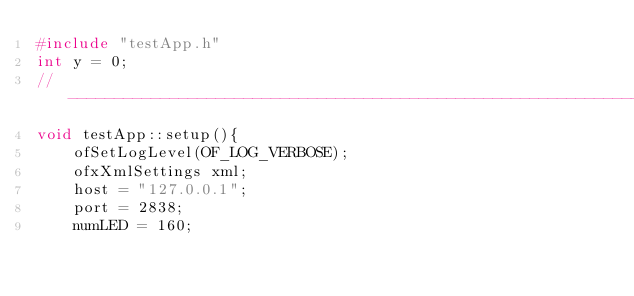Convert code to text. <code><loc_0><loc_0><loc_500><loc_500><_C++_>#include "testApp.h"
int y = 0;
//--------------------------------------------------------------
void testApp::setup(){
    ofSetLogLevel(OF_LOG_VERBOSE);
    ofxXmlSettings xml;
    host = "127.0.0.1";
    port = 2838;
    numLED = 160;</code> 